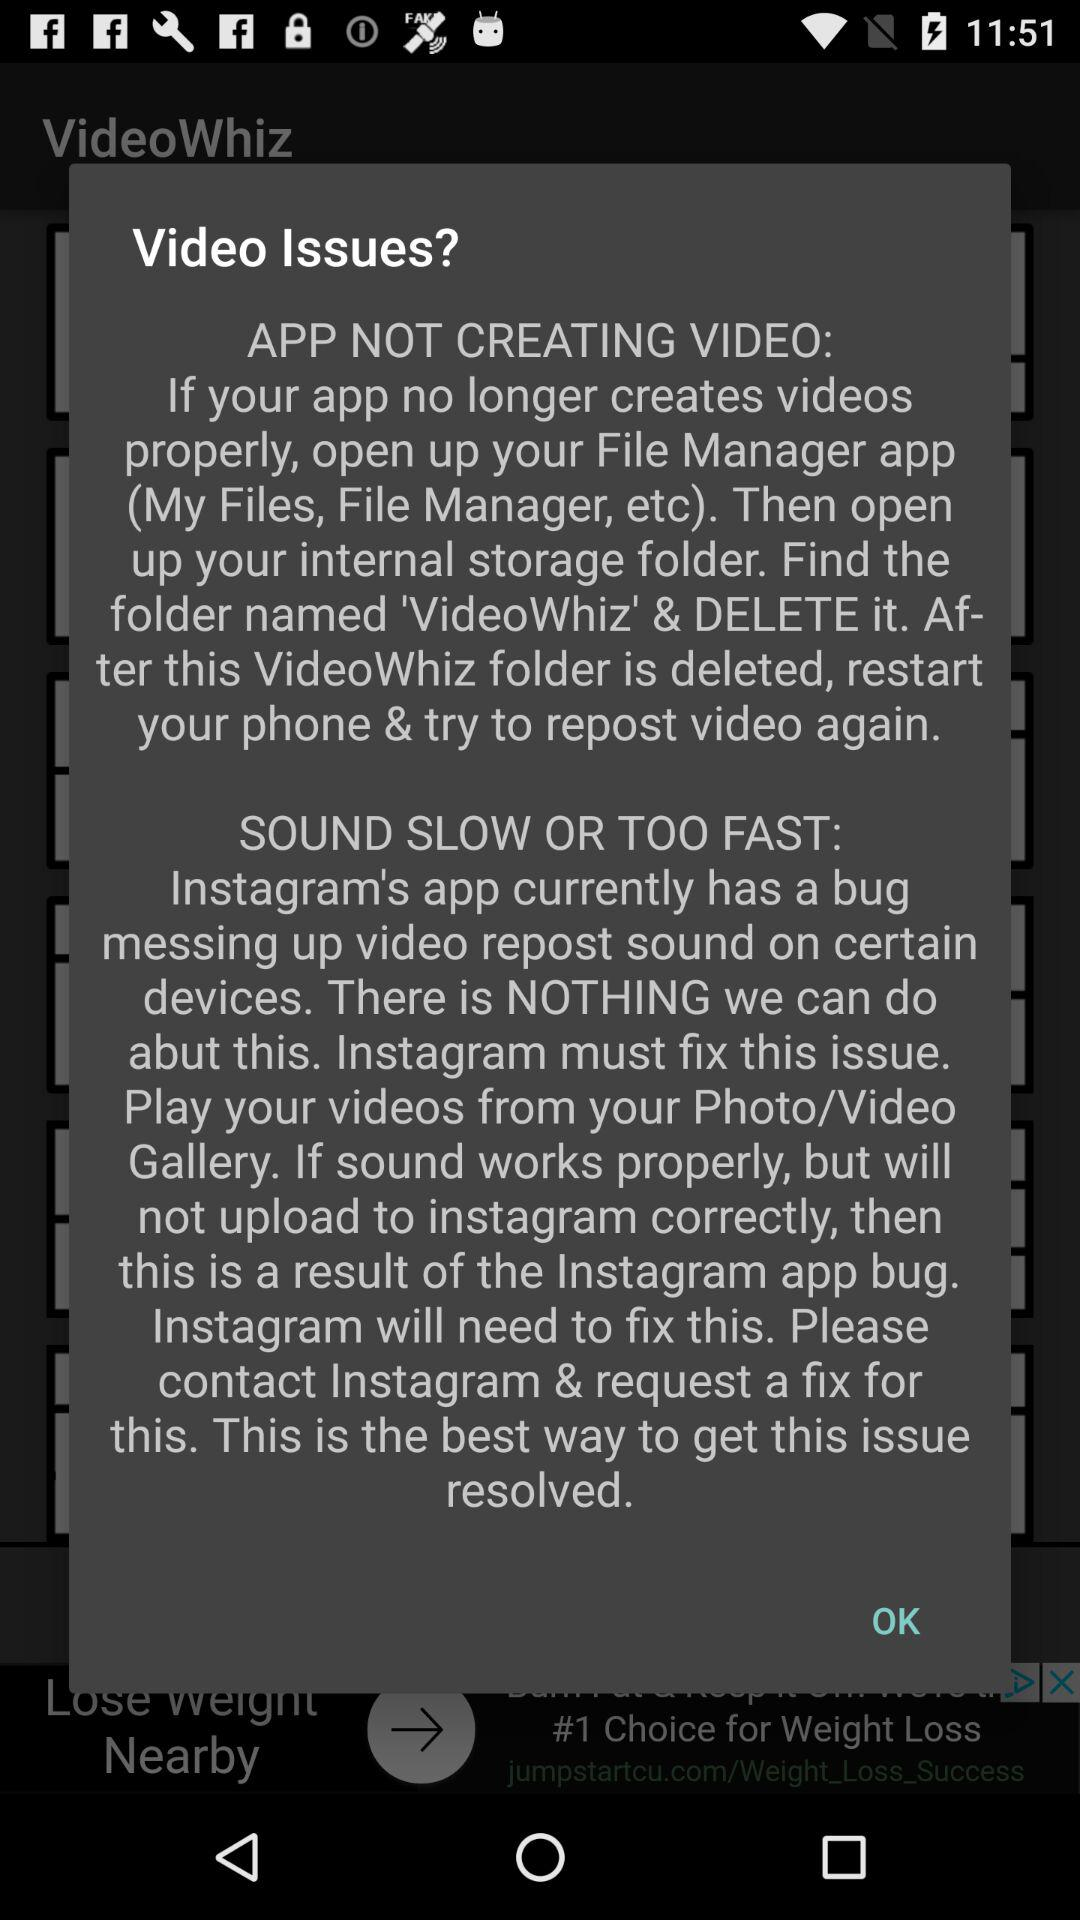What application folder needs to be deleted if videos are not created properly? If videos are not properly created, the application folder VideoWhiz needs to be deleted. 